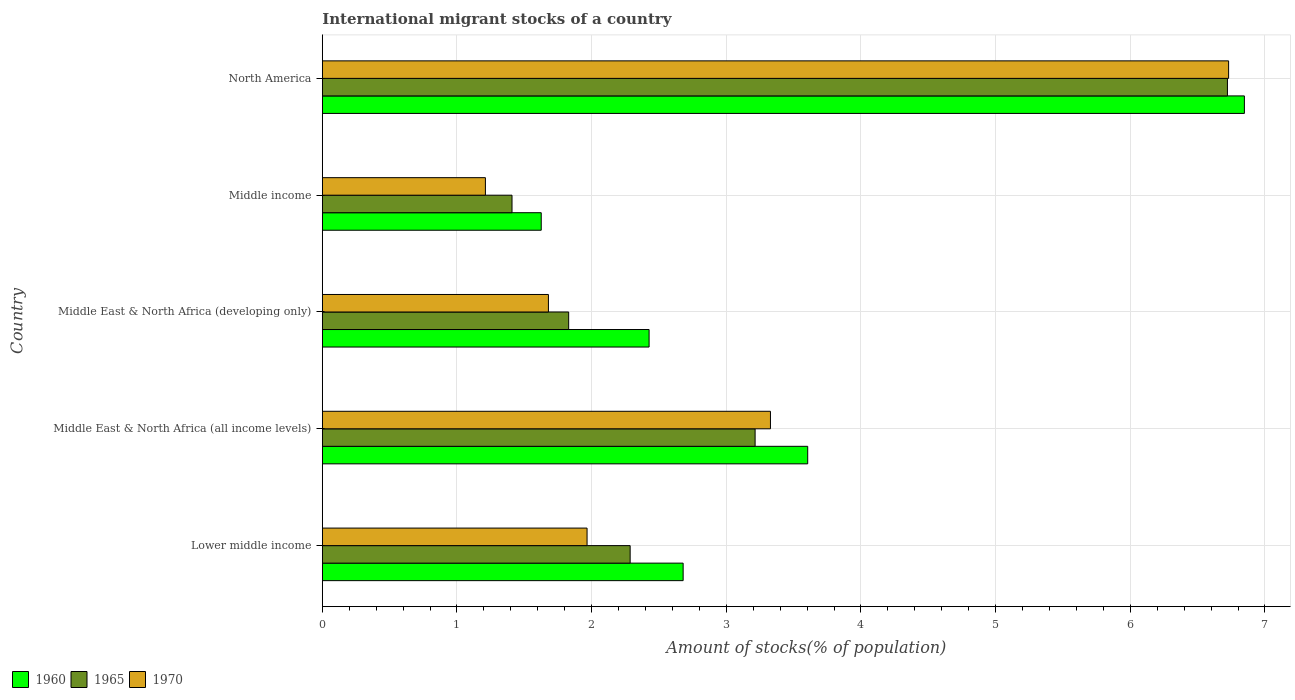Are the number of bars on each tick of the Y-axis equal?
Give a very brief answer. Yes. How many bars are there on the 4th tick from the top?
Offer a very short reply. 3. How many bars are there on the 2nd tick from the bottom?
Offer a terse response. 3. In how many cases, is the number of bars for a given country not equal to the number of legend labels?
Ensure brevity in your answer.  0. What is the amount of stocks in in 1960 in Middle East & North Africa (developing only)?
Your response must be concise. 2.43. Across all countries, what is the maximum amount of stocks in in 1960?
Make the answer very short. 6.85. Across all countries, what is the minimum amount of stocks in in 1965?
Ensure brevity in your answer.  1.41. In which country was the amount of stocks in in 1965 maximum?
Your response must be concise. North America. In which country was the amount of stocks in in 1970 minimum?
Your answer should be compact. Middle income. What is the total amount of stocks in in 1965 in the graph?
Keep it short and to the point. 15.46. What is the difference between the amount of stocks in in 1960 in Middle East & North Africa (all income levels) and that in Middle East & North Africa (developing only)?
Ensure brevity in your answer.  1.18. What is the difference between the amount of stocks in in 1960 in Lower middle income and the amount of stocks in in 1965 in North America?
Offer a very short reply. -4.04. What is the average amount of stocks in in 1965 per country?
Provide a succinct answer. 3.09. What is the difference between the amount of stocks in in 1960 and amount of stocks in in 1970 in Lower middle income?
Give a very brief answer. 0.71. What is the ratio of the amount of stocks in in 1965 in Middle income to that in North America?
Your answer should be very brief. 0.21. What is the difference between the highest and the second highest amount of stocks in in 1960?
Offer a very short reply. 3.24. What is the difference between the highest and the lowest amount of stocks in in 1970?
Offer a terse response. 5.52. In how many countries, is the amount of stocks in in 1965 greater than the average amount of stocks in in 1965 taken over all countries?
Give a very brief answer. 2. Is the sum of the amount of stocks in in 1965 in Lower middle income and Middle East & North Africa (all income levels) greater than the maximum amount of stocks in in 1960 across all countries?
Your response must be concise. No. What does the 3rd bar from the top in North America represents?
Keep it short and to the point. 1960. What does the 2nd bar from the bottom in North America represents?
Keep it short and to the point. 1965. Is it the case that in every country, the sum of the amount of stocks in in 1965 and amount of stocks in in 1970 is greater than the amount of stocks in in 1960?
Give a very brief answer. Yes. How many bars are there?
Your answer should be compact. 15. Are all the bars in the graph horizontal?
Your answer should be very brief. Yes. How many countries are there in the graph?
Ensure brevity in your answer.  5. Does the graph contain any zero values?
Offer a very short reply. No. Does the graph contain grids?
Make the answer very short. Yes. How many legend labels are there?
Provide a succinct answer. 3. How are the legend labels stacked?
Your answer should be compact. Horizontal. What is the title of the graph?
Offer a very short reply. International migrant stocks of a country. What is the label or title of the X-axis?
Ensure brevity in your answer.  Amount of stocks(% of population). What is the Amount of stocks(% of population) of 1960 in Lower middle income?
Keep it short and to the point. 2.68. What is the Amount of stocks(% of population) in 1965 in Lower middle income?
Provide a short and direct response. 2.29. What is the Amount of stocks(% of population) in 1970 in Lower middle income?
Keep it short and to the point. 1.97. What is the Amount of stocks(% of population) of 1960 in Middle East & North Africa (all income levels)?
Offer a very short reply. 3.6. What is the Amount of stocks(% of population) of 1965 in Middle East & North Africa (all income levels)?
Offer a terse response. 3.21. What is the Amount of stocks(% of population) in 1970 in Middle East & North Africa (all income levels)?
Ensure brevity in your answer.  3.33. What is the Amount of stocks(% of population) of 1960 in Middle East & North Africa (developing only)?
Your answer should be very brief. 2.43. What is the Amount of stocks(% of population) in 1965 in Middle East & North Africa (developing only)?
Your answer should be very brief. 1.83. What is the Amount of stocks(% of population) of 1970 in Middle East & North Africa (developing only)?
Make the answer very short. 1.68. What is the Amount of stocks(% of population) in 1960 in Middle income?
Your response must be concise. 1.63. What is the Amount of stocks(% of population) of 1965 in Middle income?
Ensure brevity in your answer.  1.41. What is the Amount of stocks(% of population) of 1970 in Middle income?
Your response must be concise. 1.21. What is the Amount of stocks(% of population) in 1960 in North America?
Offer a very short reply. 6.85. What is the Amount of stocks(% of population) in 1965 in North America?
Offer a terse response. 6.72. What is the Amount of stocks(% of population) of 1970 in North America?
Your response must be concise. 6.73. Across all countries, what is the maximum Amount of stocks(% of population) of 1960?
Offer a very short reply. 6.85. Across all countries, what is the maximum Amount of stocks(% of population) of 1965?
Your answer should be compact. 6.72. Across all countries, what is the maximum Amount of stocks(% of population) in 1970?
Your answer should be compact. 6.73. Across all countries, what is the minimum Amount of stocks(% of population) in 1960?
Provide a short and direct response. 1.63. Across all countries, what is the minimum Amount of stocks(% of population) in 1965?
Provide a short and direct response. 1.41. Across all countries, what is the minimum Amount of stocks(% of population) in 1970?
Give a very brief answer. 1.21. What is the total Amount of stocks(% of population) in 1960 in the graph?
Your answer should be compact. 17.18. What is the total Amount of stocks(% of population) in 1965 in the graph?
Your response must be concise. 15.46. What is the total Amount of stocks(% of population) in 1970 in the graph?
Keep it short and to the point. 14.91. What is the difference between the Amount of stocks(% of population) of 1960 in Lower middle income and that in Middle East & North Africa (all income levels)?
Ensure brevity in your answer.  -0.93. What is the difference between the Amount of stocks(% of population) of 1965 in Lower middle income and that in Middle East & North Africa (all income levels)?
Give a very brief answer. -0.93. What is the difference between the Amount of stocks(% of population) in 1970 in Lower middle income and that in Middle East & North Africa (all income levels)?
Your answer should be very brief. -1.36. What is the difference between the Amount of stocks(% of population) of 1960 in Lower middle income and that in Middle East & North Africa (developing only)?
Your answer should be compact. 0.25. What is the difference between the Amount of stocks(% of population) in 1965 in Lower middle income and that in Middle East & North Africa (developing only)?
Your answer should be very brief. 0.46. What is the difference between the Amount of stocks(% of population) in 1970 in Lower middle income and that in Middle East & North Africa (developing only)?
Provide a succinct answer. 0.29. What is the difference between the Amount of stocks(% of population) in 1960 in Lower middle income and that in Middle income?
Make the answer very short. 1.05. What is the difference between the Amount of stocks(% of population) in 1965 in Lower middle income and that in Middle income?
Offer a very short reply. 0.88. What is the difference between the Amount of stocks(% of population) in 1970 in Lower middle income and that in Middle income?
Your response must be concise. 0.76. What is the difference between the Amount of stocks(% of population) in 1960 in Lower middle income and that in North America?
Give a very brief answer. -4.17. What is the difference between the Amount of stocks(% of population) in 1965 in Lower middle income and that in North America?
Ensure brevity in your answer.  -4.44. What is the difference between the Amount of stocks(% of population) in 1970 in Lower middle income and that in North America?
Offer a terse response. -4.76. What is the difference between the Amount of stocks(% of population) in 1960 in Middle East & North Africa (all income levels) and that in Middle East & North Africa (developing only)?
Ensure brevity in your answer.  1.18. What is the difference between the Amount of stocks(% of population) of 1965 in Middle East & North Africa (all income levels) and that in Middle East & North Africa (developing only)?
Offer a terse response. 1.38. What is the difference between the Amount of stocks(% of population) in 1970 in Middle East & North Africa (all income levels) and that in Middle East & North Africa (developing only)?
Ensure brevity in your answer.  1.65. What is the difference between the Amount of stocks(% of population) of 1960 in Middle East & North Africa (all income levels) and that in Middle income?
Offer a very short reply. 1.98. What is the difference between the Amount of stocks(% of population) of 1965 in Middle East & North Africa (all income levels) and that in Middle income?
Ensure brevity in your answer.  1.81. What is the difference between the Amount of stocks(% of population) in 1970 in Middle East & North Africa (all income levels) and that in Middle income?
Offer a terse response. 2.12. What is the difference between the Amount of stocks(% of population) in 1960 in Middle East & North Africa (all income levels) and that in North America?
Your answer should be compact. -3.24. What is the difference between the Amount of stocks(% of population) in 1965 in Middle East & North Africa (all income levels) and that in North America?
Provide a short and direct response. -3.51. What is the difference between the Amount of stocks(% of population) in 1970 in Middle East & North Africa (all income levels) and that in North America?
Your answer should be very brief. -3.4. What is the difference between the Amount of stocks(% of population) in 1960 in Middle East & North Africa (developing only) and that in Middle income?
Keep it short and to the point. 0.8. What is the difference between the Amount of stocks(% of population) of 1965 in Middle East & North Africa (developing only) and that in Middle income?
Your answer should be very brief. 0.42. What is the difference between the Amount of stocks(% of population) of 1970 in Middle East & North Africa (developing only) and that in Middle income?
Offer a very short reply. 0.47. What is the difference between the Amount of stocks(% of population) of 1960 in Middle East & North Africa (developing only) and that in North America?
Your answer should be compact. -4.42. What is the difference between the Amount of stocks(% of population) in 1965 in Middle East & North Africa (developing only) and that in North America?
Provide a short and direct response. -4.89. What is the difference between the Amount of stocks(% of population) in 1970 in Middle East & North Africa (developing only) and that in North America?
Your answer should be compact. -5.05. What is the difference between the Amount of stocks(% of population) of 1960 in Middle income and that in North America?
Offer a terse response. -5.22. What is the difference between the Amount of stocks(% of population) of 1965 in Middle income and that in North America?
Your answer should be compact. -5.31. What is the difference between the Amount of stocks(% of population) of 1970 in Middle income and that in North America?
Keep it short and to the point. -5.52. What is the difference between the Amount of stocks(% of population) in 1960 in Lower middle income and the Amount of stocks(% of population) in 1965 in Middle East & North Africa (all income levels)?
Give a very brief answer. -0.53. What is the difference between the Amount of stocks(% of population) in 1960 in Lower middle income and the Amount of stocks(% of population) in 1970 in Middle East & North Africa (all income levels)?
Provide a succinct answer. -0.65. What is the difference between the Amount of stocks(% of population) of 1965 in Lower middle income and the Amount of stocks(% of population) of 1970 in Middle East & North Africa (all income levels)?
Ensure brevity in your answer.  -1.04. What is the difference between the Amount of stocks(% of population) in 1960 in Lower middle income and the Amount of stocks(% of population) in 1965 in Middle East & North Africa (developing only)?
Ensure brevity in your answer.  0.85. What is the difference between the Amount of stocks(% of population) in 1965 in Lower middle income and the Amount of stocks(% of population) in 1970 in Middle East & North Africa (developing only)?
Offer a terse response. 0.61. What is the difference between the Amount of stocks(% of population) of 1960 in Lower middle income and the Amount of stocks(% of population) of 1965 in Middle income?
Your answer should be compact. 1.27. What is the difference between the Amount of stocks(% of population) in 1960 in Lower middle income and the Amount of stocks(% of population) in 1970 in Middle income?
Offer a very short reply. 1.47. What is the difference between the Amount of stocks(% of population) in 1965 in Lower middle income and the Amount of stocks(% of population) in 1970 in Middle income?
Your response must be concise. 1.07. What is the difference between the Amount of stocks(% of population) of 1960 in Lower middle income and the Amount of stocks(% of population) of 1965 in North America?
Provide a short and direct response. -4.04. What is the difference between the Amount of stocks(% of population) of 1960 in Lower middle income and the Amount of stocks(% of population) of 1970 in North America?
Provide a short and direct response. -4.05. What is the difference between the Amount of stocks(% of population) in 1965 in Lower middle income and the Amount of stocks(% of population) in 1970 in North America?
Your response must be concise. -4.44. What is the difference between the Amount of stocks(% of population) in 1960 in Middle East & North Africa (all income levels) and the Amount of stocks(% of population) in 1965 in Middle East & North Africa (developing only)?
Give a very brief answer. 1.78. What is the difference between the Amount of stocks(% of population) in 1960 in Middle East & North Africa (all income levels) and the Amount of stocks(% of population) in 1970 in Middle East & North Africa (developing only)?
Your answer should be very brief. 1.93. What is the difference between the Amount of stocks(% of population) in 1965 in Middle East & North Africa (all income levels) and the Amount of stocks(% of population) in 1970 in Middle East & North Africa (developing only)?
Offer a terse response. 1.53. What is the difference between the Amount of stocks(% of population) of 1960 in Middle East & North Africa (all income levels) and the Amount of stocks(% of population) of 1965 in Middle income?
Give a very brief answer. 2.2. What is the difference between the Amount of stocks(% of population) of 1960 in Middle East & North Africa (all income levels) and the Amount of stocks(% of population) of 1970 in Middle income?
Make the answer very short. 2.39. What is the difference between the Amount of stocks(% of population) of 1965 in Middle East & North Africa (all income levels) and the Amount of stocks(% of population) of 1970 in Middle income?
Offer a terse response. 2. What is the difference between the Amount of stocks(% of population) in 1960 in Middle East & North Africa (all income levels) and the Amount of stocks(% of population) in 1965 in North America?
Ensure brevity in your answer.  -3.12. What is the difference between the Amount of stocks(% of population) in 1960 in Middle East & North Africa (all income levels) and the Amount of stocks(% of population) in 1970 in North America?
Your answer should be compact. -3.13. What is the difference between the Amount of stocks(% of population) of 1965 in Middle East & North Africa (all income levels) and the Amount of stocks(% of population) of 1970 in North America?
Provide a short and direct response. -3.52. What is the difference between the Amount of stocks(% of population) of 1960 in Middle East & North Africa (developing only) and the Amount of stocks(% of population) of 1970 in Middle income?
Provide a short and direct response. 1.22. What is the difference between the Amount of stocks(% of population) in 1965 in Middle East & North Africa (developing only) and the Amount of stocks(% of population) in 1970 in Middle income?
Your answer should be very brief. 0.62. What is the difference between the Amount of stocks(% of population) in 1960 in Middle East & North Africa (developing only) and the Amount of stocks(% of population) in 1965 in North America?
Your response must be concise. -4.29. What is the difference between the Amount of stocks(% of population) in 1960 in Middle East & North Africa (developing only) and the Amount of stocks(% of population) in 1970 in North America?
Provide a short and direct response. -4.3. What is the difference between the Amount of stocks(% of population) of 1965 in Middle East & North Africa (developing only) and the Amount of stocks(% of population) of 1970 in North America?
Give a very brief answer. -4.9. What is the difference between the Amount of stocks(% of population) of 1960 in Middle income and the Amount of stocks(% of population) of 1965 in North America?
Provide a short and direct response. -5.1. What is the difference between the Amount of stocks(% of population) of 1960 in Middle income and the Amount of stocks(% of population) of 1970 in North America?
Offer a very short reply. -5.1. What is the difference between the Amount of stocks(% of population) in 1965 in Middle income and the Amount of stocks(% of population) in 1970 in North America?
Give a very brief answer. -5.32. What is the average Amount of stocks(% of population) of 1960 per country?
Provide a succinct answer. 3.44. What is the average Amount of stocks(% of population) in 1965 per country?
Keep it short and to the point. 3.09. What is the average Amount of stocks(% of population) in 1970 per country?
Make the answer very short. 2.98. What is the difference between the Amount of stocks(% of population) in 1960 and Amount of stocks(% of population) in 1965 in Lower middle income?
Your answer should be very brief. 0.39. What is the difference between the Amount of stocks(% of population) of 1960 and Amount of stocks(% of population) of 1970 in Lower middle income?
Your response must be concise. 0.71. What is the difference between the Amount of stocks(% of population) in 1965 and Amount of stocks(% of population) in 1970 in Lower middle income?
Your answer should be very brief. 0.32. What is the difference between the Amount of stocks(% of population) of 1960 and Amount of stocks(% of population) of 1965 in Middle East & North Africa (all income levels)?
Provide a short and direct response. 0.39. What is the difference between the Amount of stocks(% of population) in 1960 and Amount of stocks(% of population) in 1970 in Middle East & North Africa (all income levels)?
Offer a terse response. 0.28. What is the difference between the Amount of stocks(% of population) in 1965 and Amount of stocks(% of population) in 1970 in Middle East & North Africa (all income levels)?
Ensure brevity in your answer.  -0.11. What is the difference between the Amount of stocks(% of population) of 1960 and Amount of stocks(% of population) of 1965 in Middle East & North Africa (developing only)?
Provide a succinct answer. 0.6. What is the difference between the Amount of stocks(% of population) of 1960 and Amount of stocks(% of population) of 1970 in Middle East & North Africa (developing only)?
Provide a succinct answer. 0.75. What is the difference between the Amount of stocks(% of population) in 1965 and Amount of stocks(% of population) in 1970 in Middle East & North Africa (developing only)?
Keep it short and to the point. 0.15. What is the difference between the Amount of stocks(% of population) of 1960 and Amount of stocks(% of population) of 1965 in Middle income?
Keep it short and to the point. 0.22. What is the difference between the Amount of stocks(% of population) in 1960 and Amount of stocks(% of population) in 1970 in Middle income?
Your answer should be very brief. 0.41. What is the difference between the Amount of stocks(% of population) in 1965 and Amount of stocks(% of population) in 1970 in Middle income?
Your answer should be very brief. 0.2. What is the difference between the Amount of stocks(% of population) in 1960 and Amount of stocks(% of population) in 1965 in North America?
Your answer should be very brief. 0.13. What is the difference between the Amount of stocks(% of population) in 1960 and Amount of stocks(% of population) in 1970 in North America?
Your answer should be very brief. 0.12. What is the difference between the Amount of stocks(% of population) in 1965 and Amount of stocks(% of population) in 1970 in North America?
Your answer should be very brief. -0.01. What is the ratio of the Amount of stocks(% of population) of 1960 in Lower middle income to that in Middle East & North Africa (all income levels)?
Make the answer very short. 0.74. What is the ratio of the Amount of stocks(% of population) of 1965 in Lower middle income to that in Middle East & North Africa (all income levels)?
Your response must be concise. 0.71. What is the ratio of the Amount of stocks(% of population) in 1970 in Lower middle income to that in Middle East & North Africa (all income levels)?
Your answer should be very brief. 0.59. What is the ratio of the Amount of stocks(% of population) of 1960 in Lower middle income to that in Middle East & North Africa (developing only)?
Offer a terse response. 1.1. What is the ratio of the Amount of stocks(% of population) of 1965 in Lower middle income to that in Middle East & North Africa (developing only)?
Your answer should be very brief. 1.25. What is the ratio of the Amount of stocks(% of population) in 1970 in Lower middle income to that in Middle East & North Africa (developing only)?
Keep it short and to the point. 1.17. What is the ratio of the Amount of stocks(% of population) in 1960 in Lower middle income to that in Middle income?
Provide a succinct answer. 1.65. What is the ratio of the Amount of stocks(% of population) of 1965 in Lower middle income to that in Middle income?
Give a very brief answer. 1.62. What is the ratio of the Amount of stocks(% of population) of 1970 in Lower middle income to that in Middle income?
Offer a very short reply. 1.62. What is the ratio of the Amount of stocks(% of population) of 1960 in Lower middle income to that in North America?
Your answer should be compact. 0.39. What is the ratio of the Amount of stocks(% of population) in 1965 in Lower middle income to that in North America?
Keep it short and to the point. 0.34. What is the ratio of the Amount of stocks(% of population) in 1970 in Lower middle income to that in North America?
Offer a very short reply. 0.29. What is the ratio of the Amount of stocks(% of population) of 1960 in Middle East & North Africa (all income levels) to that in Middle East & North Africa (developing only)?
Ensure brevity in your answer.  1.49. What is the ratio of the Amount of stocks(% of population) of 1965 in Middle East & North Africa (all income levels) to that in Middle East & North Africa (developing only)?
Offer a terse response. 1.76. What is the ratio of the Amount of stocks(% of population) in 1970 in Middle East & North Africa (all income levels) to that in Middle East & North Africa (developing only)?
Your response must be concise. 1.98. What is the ratio of the Amount of stocks(% of population) in 1960 in Middle East & North Africa (all income levels) to that in Middle income?
Keep it short and to the point. 2.22. What is the ratio of the Amount of stocks(% of population) of 1965 in Middle East & North Africa (all income levels) to that in Middle income?
Provide a succinct answer. 2.28. What is the ratio of the Amount of stocks(% of population) in 1970 in Middle East & North Africa (all income levels) to that in Middle income?
Your answer should be very brief. 2.75. What is the ratio of the Amount of stocks(% of population) in 1960 in Middle East & North Africa (all income levels) to that in North America?
Your response must be concise. 0.53. What is the ratio of the Amount of stocks(% of population) of 1965 in Middle East & North Africa (all income levels) to that in North America?
Provide a short and direct response. 0.48. What is the ratio of the Amount of stocks(% of population) of 1970 in Middle East & North Africa (all income levels) to that in North America?
Ensure brevity in your answer.  0.49. What is the ratio of the Amount of stocks(% of population) of 1960 in Middle East & North Africa (developing only) to that in Middle income?
Give a very brief answer. 1.49. What is the ratio of the Amount of stocks(% of population) of 1965 in Middle East & North Africa (developing only) to that in Middle income?
Provide a short and direct response. 1.3. What is the ratio of the Amount of stocks(% of population) in 1970 in Middle East & North Africa (developing only) to that in Middle income?
Keep it short and to the point. 1.39. What is the ratio of the Amount of stocks(% of population) of 1960 in Middle East & North Africa (developing only) to that in North America?
Your answer should be compact. 0.35. What is the ratio of the Amount of stocks(% of population) in 1965 in Middle East & North Africa (developing only) to that in North America?
Make the answer very short. 0.27. What is the ratio of the Amount of stocks(% of population) in 1970 in Middle East & North Africa (developing only) to that in North America?
Make the answer very short. 0.25. What is the ratio of the Amount of stocks(% of population) of 1960 in Middle income to that in North America?
Offer a terse response. 0.24. What is the ratio of the Amount of stocks(% of population) of 1965 in Middle income to that in North America?
Offer a terse response. 0.21. What is the ratio of the Amount of stocks(% of population) in 1970 in Middle income to that in North America?
Keep it short and to the point. 0.18. What is the difference between the highest and the second highest Amount of stocks(% of population) of 1960?
Make the answer very short. 3.24. What is the difference between the highest and the second highest Amount of stocks(% of population) of 1965?
Give a very brief answer. 3.51. What is the difference between the highest and the second highest Amount of stocks(% of population) of 1970?
Make the answer very short. 3.4. What is the difference between the highest and the lowest Amount of stocks(% of population) of 1960?
Give a very brief answer. 5.22. What is the difference between the highest and the lowest Amount of stocks(% of population) in 1965?
Keep it short and to the point. 5.31. What is the difference between the highest and the lowest Amount of stocks(% of population) of 1970?
Give a very brief answer. 5.52. 